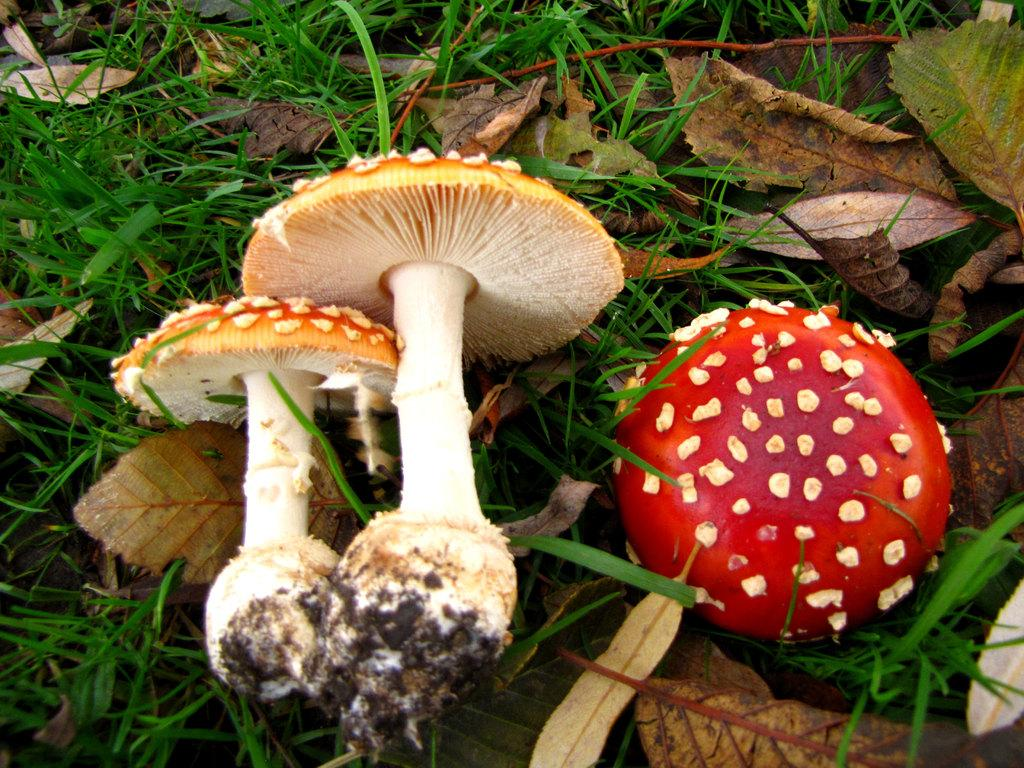What type of vegetation can be seen on the ground in the image? There are mushrooms on the ground in the image. What type of vegetation can be seen in the background of the image? There is grass visible in the background of the image. What type of attraction can be seen in the image? There is no attraction present in the image; it features mushrooms on the ground and grass in the background. What type of print is visible on the mushrooms in the image? There is no print visible on the mushrooms in the image; they appear to be natural and unaltered. 